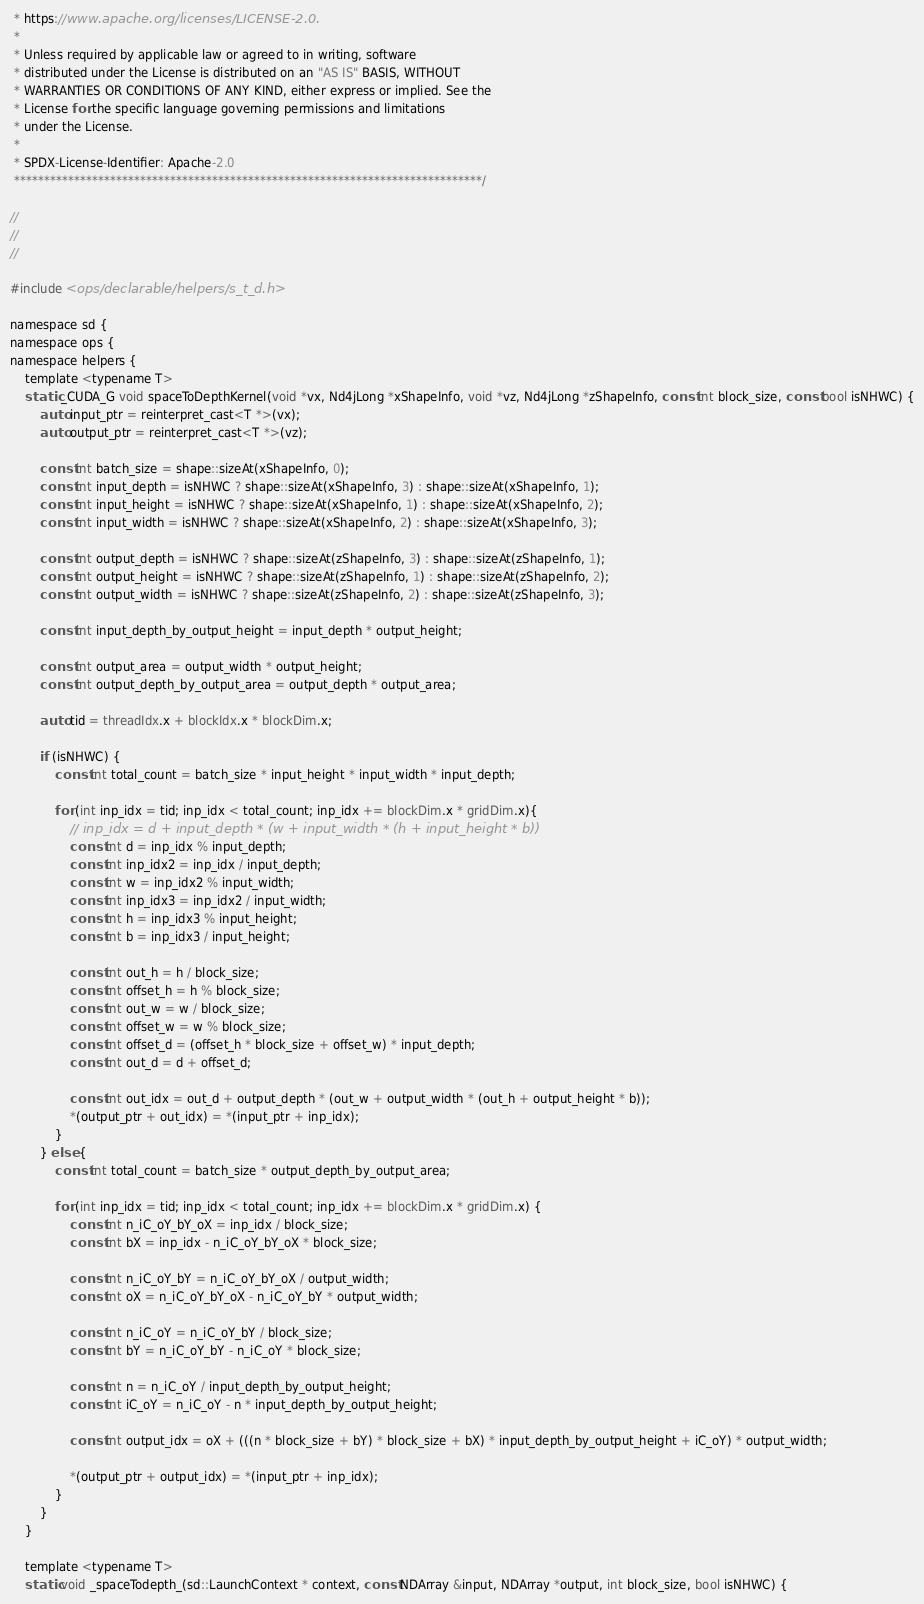<code> <loc_0><loc_0><loc_500><loc_500><_Cuda_> * https://www.apache.org/licenses/LICENSE-2.0.
 *
 * Unless required by applicable law or agreed to in writing, software
 * distributed under the License is distributed on an "AS IS" BASIS, WITHOUT
 * WARRANTIES OR CONDITIONS OF ANY KIND, either express or implied. See the
 * License for the specific language governing permissions and limitations
 * under the License.
 *
 * SPDX-License-Identifier: Apache-2.0
 ******************************************************************************/

//
//
//

#include <ops/declarable/helpers/s_t_d.h>

namespace sd {
namespace ops {
namespace helpers {
    template <typename T>
    static _CUDA_G void spaceToDepthKernel(void *vx, Nd4jLong *xShapeInfo, void *vz, Nd4jLong *zShapeInfo, const int block_size, const bool isNHWC) {
        auto input_ptr = reinterpret_cast<T *>(vx);
        auto output_ptr = reinterpret_cast<T *>(vz);

        const int batch_size = shape::sizeAt(xShapeInfo, 0);
        const int input_depth = isNHWC ? shape::sizeAt(xShapeInfo, 3) : shape::sizeAt(xShapeInfo, 1);
        const int input_height = isNHWC ? shape::sizeAt(xShapeInfo, 1) : shape::sizeAt(xShapeInfo, 2);
        const int input_width = isNHWC ? shape::sizeAt(xShapeInfo, 2) : shape::sizeAt(xShapeInfo, 3);

        const int output_depth = isNHWC ? shape::sizeAt(zShapeInfo, 3) : shape::sizeAt(zShapeInfo, 1);
        const int output_height = isNHWC ? shape::sizeAt(zShapeInfo, 1) : shape::sizeAt(zShapeInfo, 2);
        const int output_width = isNHWC ? shape::sizeAt(zShapeInfo, 2) : shape::sizeAt(zShapeInfo, 3);

        const int input_depth_by_output_height = input_depth * output_height;

        const int output_area = output_width * output_height;
        const int output_depth_by_output_area = output_depth * output_area;

        auto tid = threadIdx.x + blockIdx.x * blockDim.x;

        if (isNHWC) {
            const int total_count = batch_size * input_height * input_width * input_depth;

            for (int inp_idx = tid; inp_idx < total_count; inp_idx += blockDim.x * gridDim.x){
                // inp_idx = d + input_depth * (w + input_width * (h + input_height * b))
                const int d = inp_idx % input_depth;
                const int inp_idx2 = inp_idx / input_depth;
                const int w = inp_idx2 % input_width;
                const int inp_idx3 = inp_idx2 / input_width;
                const int h = inp_idx3 % input_height;
                const int b = inp_idx3 / input_height;

                const int out_h = h / block_size;
                const int offset_h = h % block_size;
                const int out_w = w / block_size;
                const int offset_w = w % block_size;
                const int offset_d = (offset_h * block_size + offset_w) * input_depth;
                const int out_d = d + offset_d;

                const int out_idx = out_d + output_depth * (out_w + output_width * (out_h + output_height * b));
                *(output_ptr + out_idx) = *(input_ptr + inp_idx);
            }
        } else {
            const int total_count = batch_size * output_depth_by_output_area;

            for (int inp_idx = tid; inp_idx < total_count; inp_idx += blockDim.x * gridDim.x) {
                const int n_iC_oY_bY_oX = inp_idx / block_size;
                const int bX = inp_idx - n_iC_oY_bY_oX * block_size;

                const int n_iC_oY_bY = n_iC_oY_bY_oX / output_width;
                const int oX = n_iC_oY_bY_oX - n_iC_oY_bY * output_width;

                const int n_iC_oY = n_iC_oY_bY / block_size;
                const int bY = n_iC_oY_bY - n_iC_oY * block_size;

                const int n = n_iC_oY / input_depth_by_output_height;
                const int iC_oY = n_iC_oY - n * input_depth_by_output_height;

                const int output_idx = oX + (((n * block_size + bY) * block_size + bX) * input_depth_by_output_height + iC_oY) * output_width;

                *(output_ptr + output_idx) = *(input_ptr + inp_idx);
            }
        }
    }

    template <typename T>
    static void _spaceTodepth_(sd::LaunchContext * context, const NDArray &input, NDArray *output, int block_size, bool isNHWC) {</code> 